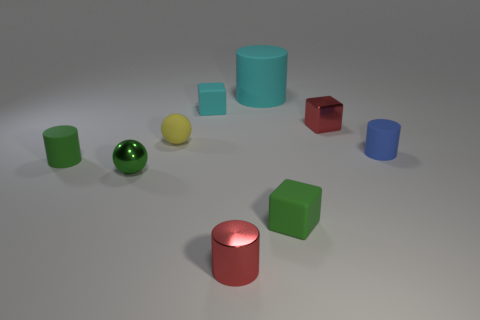Add 1 yellow objects. How many objects exist? 10 Subtract all cylinders. How many objects are left? 5 Add 4 matte cubes. How many matte cubes are left? 6 Add 5 small red objects. How many small red objects exist? 7 Subtract 1 blue cylinders. How many objects are left? 8 Subtract all cyan rubber cylinders. Subtract all red blocks. How many objects are left? 7 